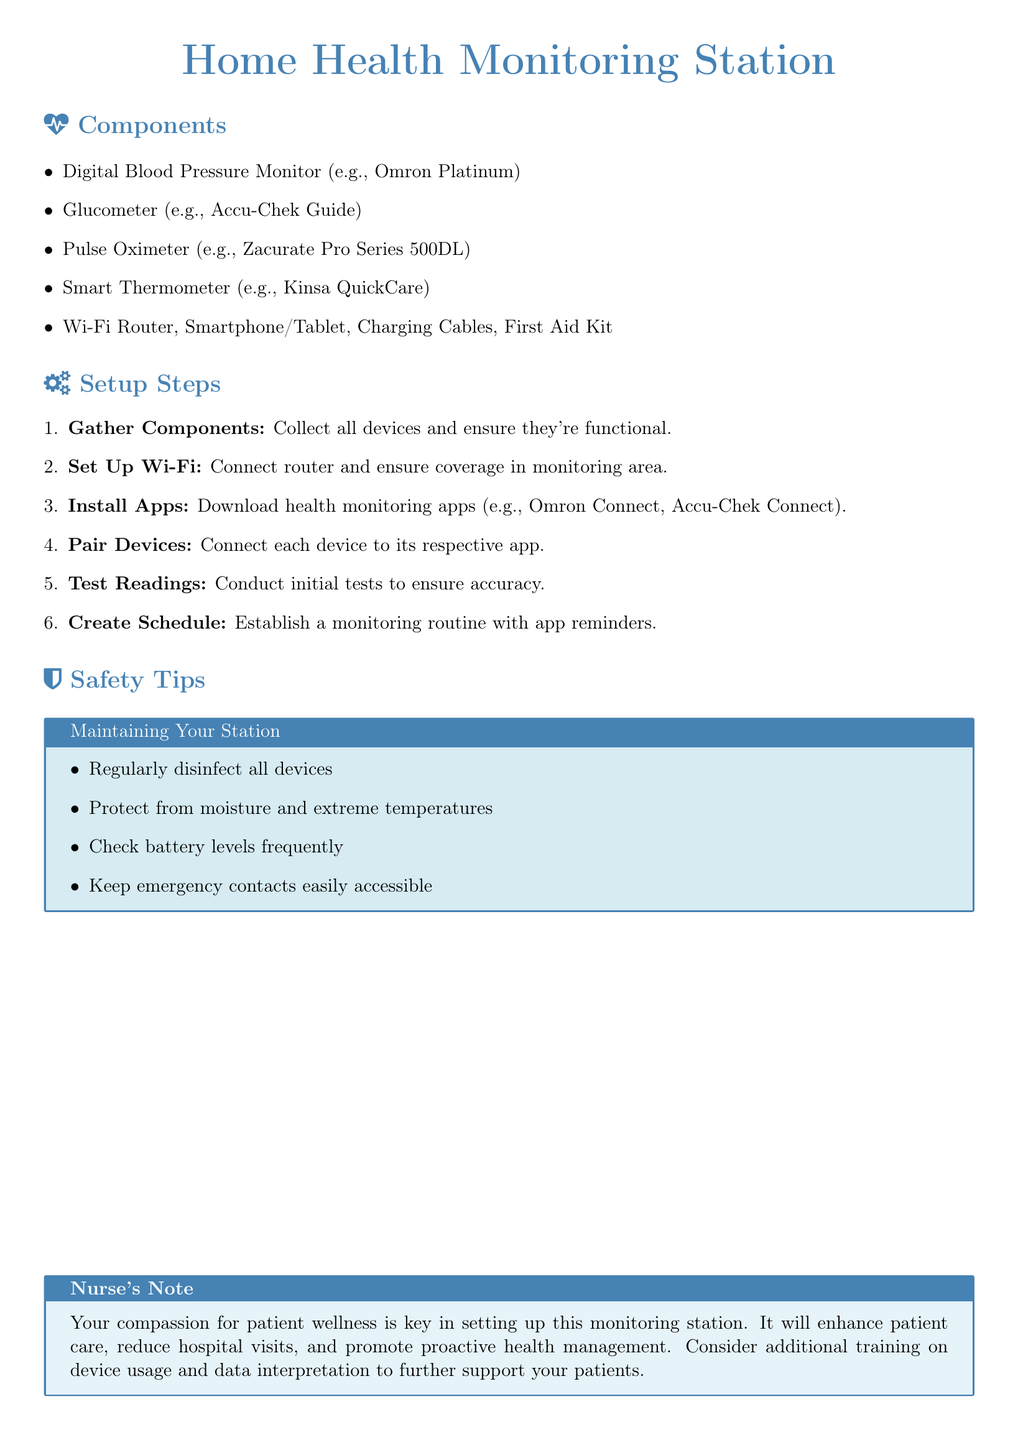What is the title of the document? The title is stated at the top of the document, which is "Home Health Monitoring Station."
Answer: Home Health Monitoring Station How many components are listed in the document? The document lists the components in a bullet point format, specifically five main devices are mentioned.
Answer: 5 What is the first setup step mentioned? The document provides a series of steps, with the first step being "Gather Components."
Answer: Gather Components Which device example is given for the Digital Blood Pressure Monitor? In the components section, an example is provided for this device as "Omron Platinum."
Answer: Omron Platinum What is the purpose of the Nurse's Note section? The Nurse's Note contains a personal message that emphasizes the importance of compassion in patient care, enhancing the overall monitoring setup.
Answer: Enhancing patient care What should be regularly done to the devices? The safety tips recommend that devices should be regularly disinfected to maintain hygiene and safety.
Answer: Disinfect How is the Wi-Fi router significant in the setup? The setup steps indicate that the Wi-Fi router is necessary for ensuring coverage in the monitoring area, highlighting its importance in the system.
Answer: Coverage What is one of the safety tips regarding emergency contacts? The document highlights keeping emergency contacts easily accessible as one of the safety measures for the monitoring station.
Answer: Easily accessible What should be established with app reminders? The document states that a monitoring routine should be created, including reminders from the apps installed.
Answer: Monitoring routine 